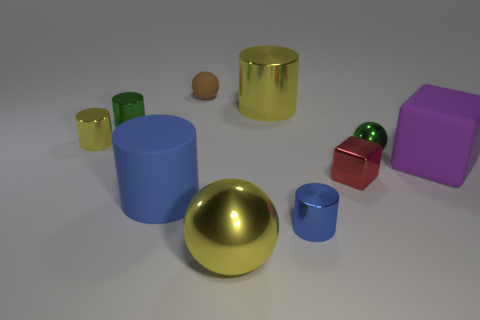Subtract all green cylinders. How many cylinders are left? 4 Subtract all metal balls. How many balls are left? 1 Subtract all gray cylinders. Subtract all cyan spheres. How many cylinders are left? 5 Subtract all balls. How many objects are left? 7 Subtract all brown matte balls. Subtract all big yellow metallic cylinders. How many objects are left? 8 Add 3 green metallic objects. How many green metallic objects are left? 5 Add 7 blue cylinders. How many blue cylinders exist? 9 Subtract 0 purple spheres. How many objects are left? 10 